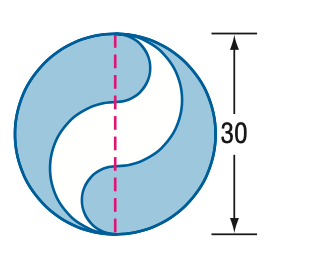Can you explain how to calculate the area of the shaded region step by step? Certainly! To calculate the area of the shaded region, you would follow these steps: First, calculate the area of the entire circle using the radius (which is half of the given diameter, so 15 units). The formula is A = πr². Then, identify the areas of the unshaded parts - these parts are shaped like a semicircle and a quarter circle. Calculate these areas and subtract them from the total area of the full circle to find the area of the shaded region. 